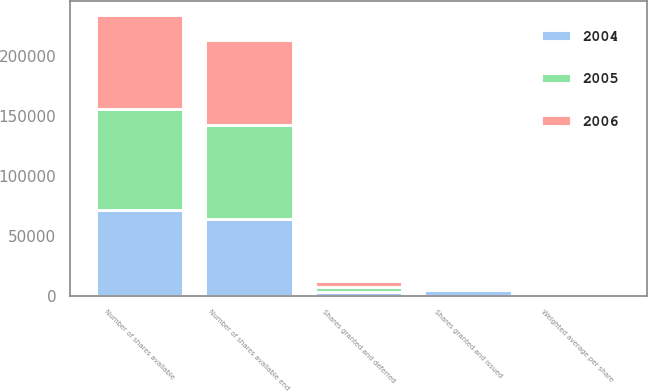<chart> <loc_0><loc_0><loc_500><loc_500><stacked_bar_chart><ecel><fcel>Number of shares available<fcel>Shares granted and issued<fcel>Shares granted and deferred<fcel>Number of shares available end<fcel>Weighted average per share<nl><fcel>2004<fcel>71553<fcel>4983<fcel>2846<fcel>63724<fcel>52.72<nl><fcel>2006<fcel>78521<fcel>1743<fcel>5225<fcel>71553<fcel>51.7<nl><fcel>2005<fcel>84611<fcel>1827<fcel>4263<fcel>78521<fcel>49.29<nl></chart> 